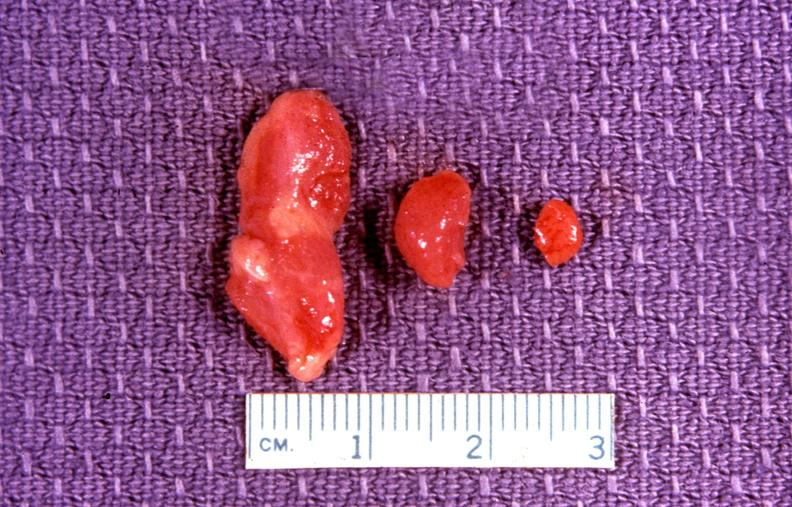what is present?
Answer the question using a single word or phrase. Endocrine 